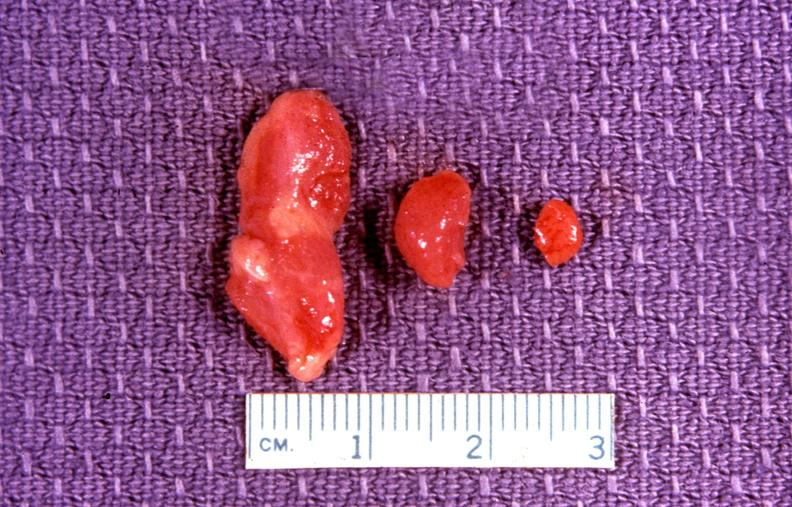what is present?
Answer the question using a single word or phrase. Endocrine 